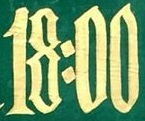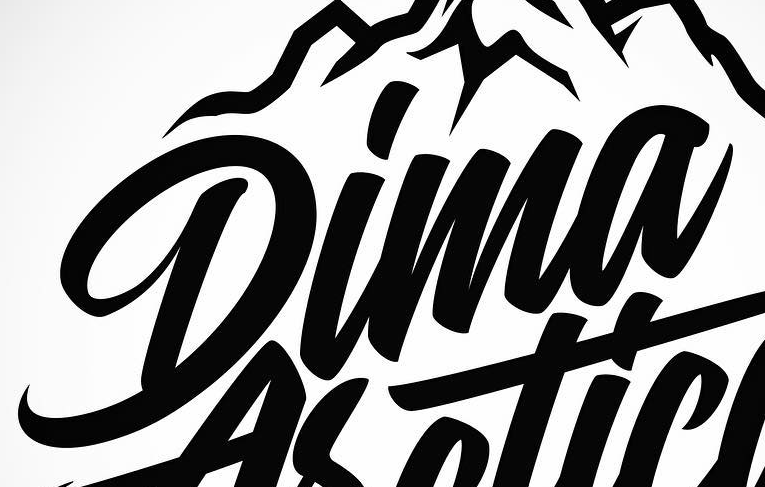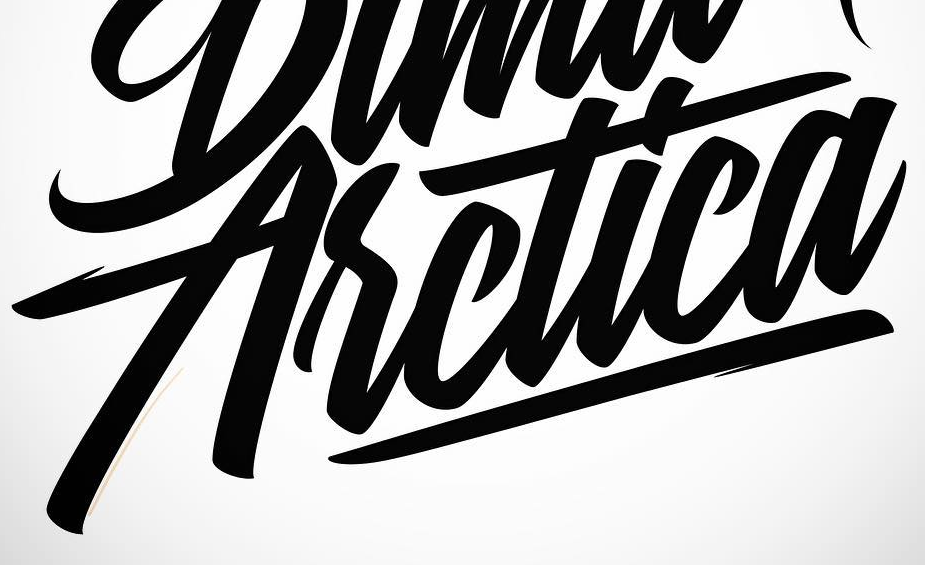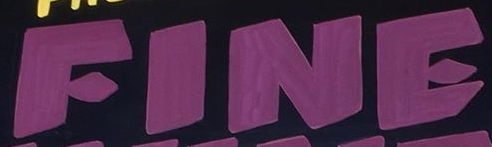What words are shown in these images in order, separated by a semicolon? 18:00; Dima; Asctica; FINE 